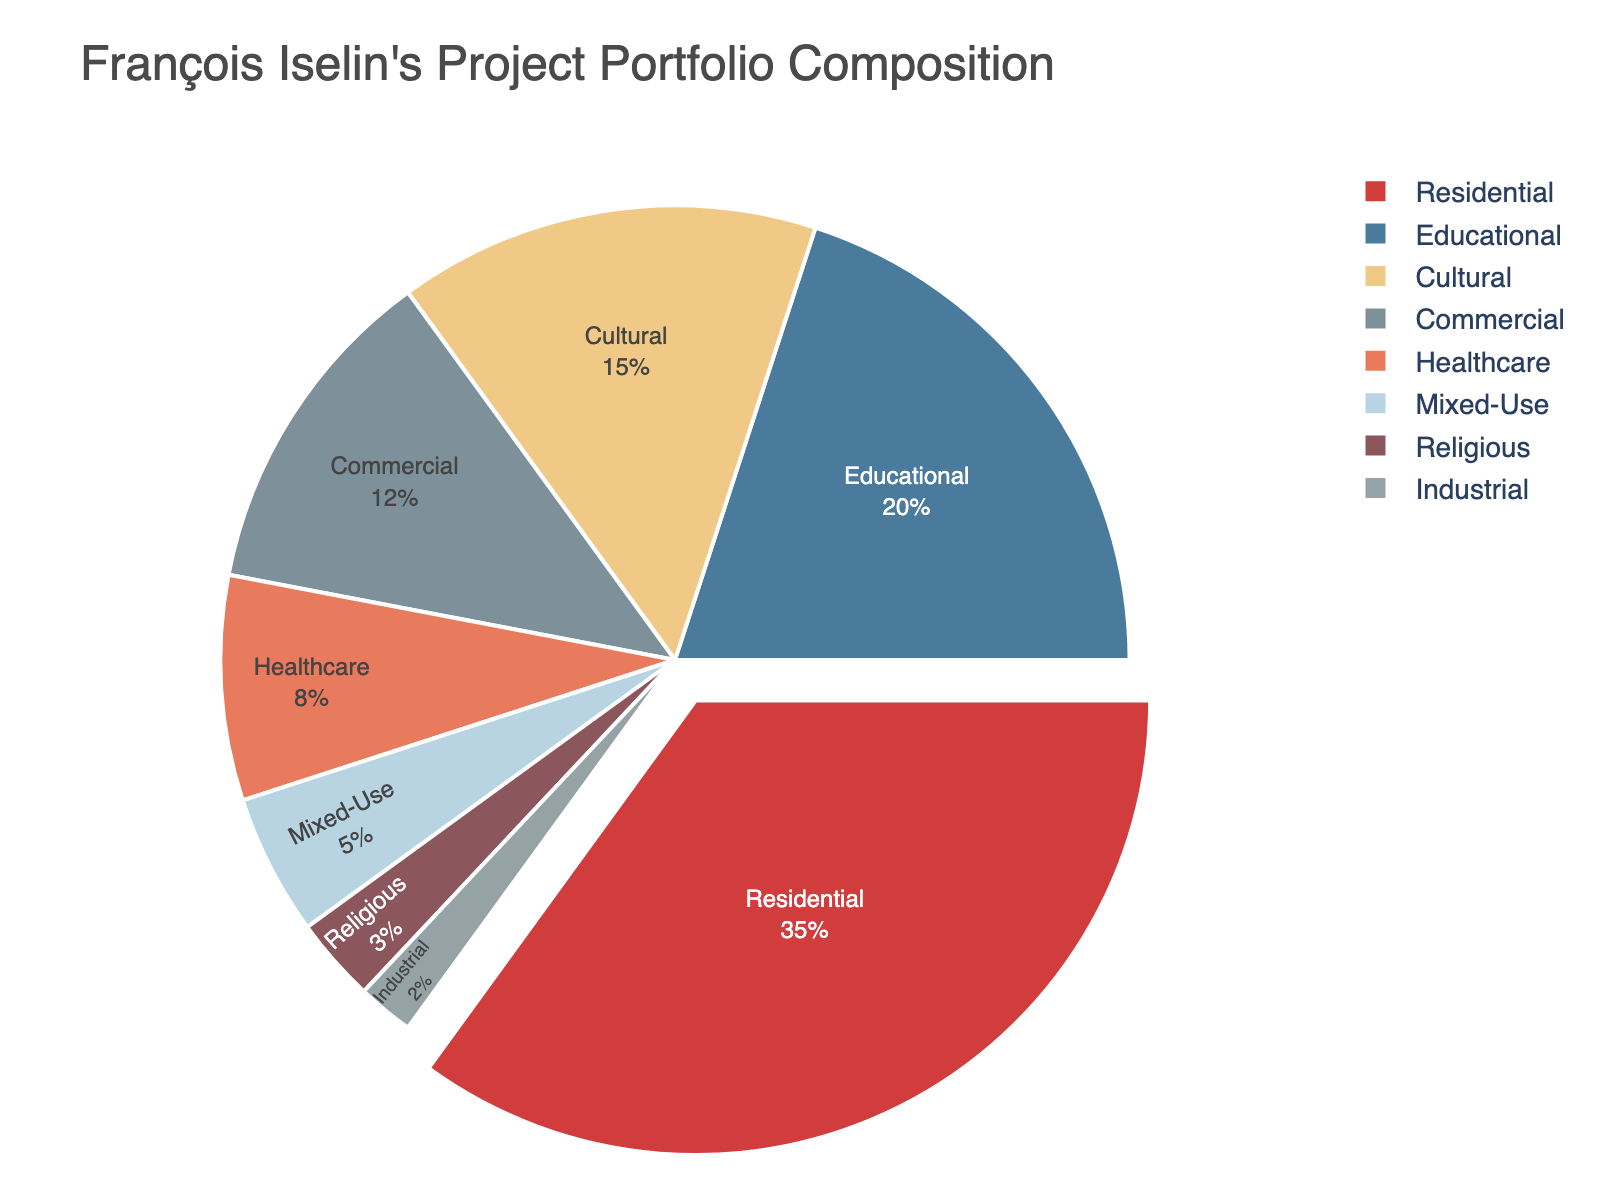What is the combined percentage of Residential and Commercial projects? To find the combined percentage, add the percentage values for Residential and Commercial projects. Residential is 35%, and Commercial is 12%. Thus, the combined percentage is 35 + 12 = 47%
Answer: 47% Which type of project has the lowest percentage in François Iselin's portfolio? Look at the pie chart and identify the segment with the smallest size. The smallest segment represents Industrial projects, which account for 2%
Answer: Industrial Is the sum of Educational and Cultural projects more or less than the sum of Healthcare and Mixed-Use projects? First, find the percentages of each type: Educational (20%), Cultural (15%), Healthcare (8%), and Mixed-Use (5%). Next, calculate the sum for Educational and Cultural: 20 + 15 = 35%. Then, calculate the sum for Healthcare and Mixed-Use: 8 + 5 = 13%. Comparing these sums shows that Educational and Cultural projects' sum (35%) is more than Healthcare and Mixed-Use projects' sum (13%)
Answer: More How much more percentage do Educational projects hold compared to Healthcare projects? Find the percentage difference between Educational and Healthcare projects. Educational is 20%, and Healthcare is 8%. The difference is 20 - 8 = 12%
Answer: 12% Which two types of projects combined make up exactly half of the portfolio? To find two types that add up to 50%, consider various pairs and check their sums. Residential (35%) + Educational (20%) = 55%; not valid. Educational (20%) + Cultural (15%) = 35%; not valid. Cultural (15%) + Commercial (12%) = 27%; not valid. Healthcare (8%) + Mixed-Use (5%) = 13%; not valid. Residential (35%) + Healthcare (8%) = 43%; not valid... After trying combinations, none add up to exactly 50%. Therefore, no such pair exists
Answer: None What percentage of François Iselin's projects are non-residential? Subtract the Residential project's percentage from 100%. Residential is 35%, so non-residential is 100 - 35 = 65%
Answer: 65% Which projects have a higher percentage: Cultural or Commercial? Compare the percentages of Cultural and Commercial projects. Cultural is 15%, and Commercial is 12%. Thus, Cultural projects have a higher percentage than Commercial
Answer: Cultural How does the proportion of Educational projects compare to the combined proportion of Religious and Industrial projects? Calculate the sum of the percentages of Religious and Industrial projects. Religious is 3% and Industrial is 2%, so their combined proportion is 3 + 2 = 5%. Educational projects alone are 20%. Hence, Educational projects are more in proportion compared to the combined proportion of Religious and Industrial
Answer: Educational 